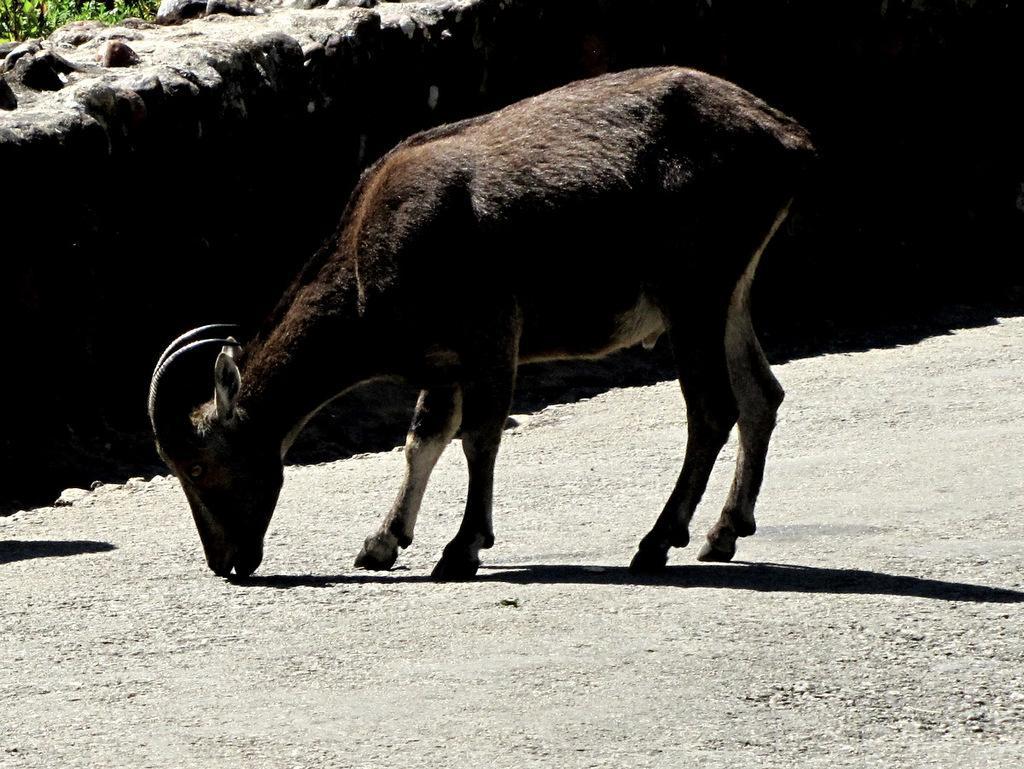Could you give a brief overview of what you see in this image? In this image I can see an animal on the ground. In the background there is a wall. 